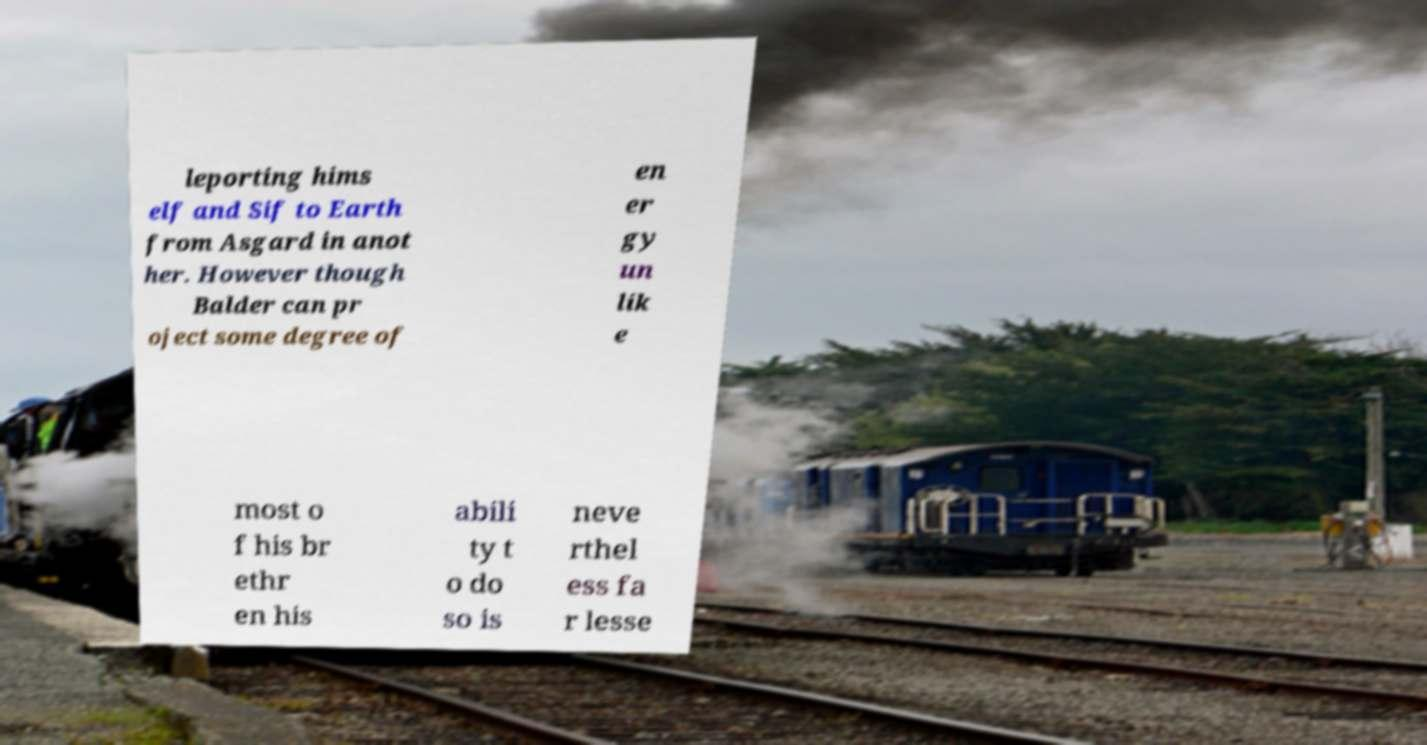Can you read and provide the text displayed in the image?This photo seems to have some interesting text. Can you extract and type it out for me? leporting hims elf and Sif to Earth from Asgard in anot her. However though Balder can pr oject some degree of en er gy un lik e most o f his br ethr en his abili ty t o do so is neve rthel ess fa r lesse 